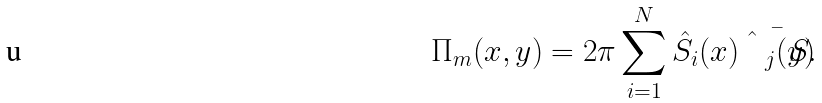<formula> <loc_0><loc_0><loc_500><loc_500>\Pi _ { m } ( x , y ) = { 2 \pi } \sum _ { i = 1 } ^ { N } \hat { S } _ { i } ( x ) \bar { \hat { S } _ { j } ( y ) } .</formula> 